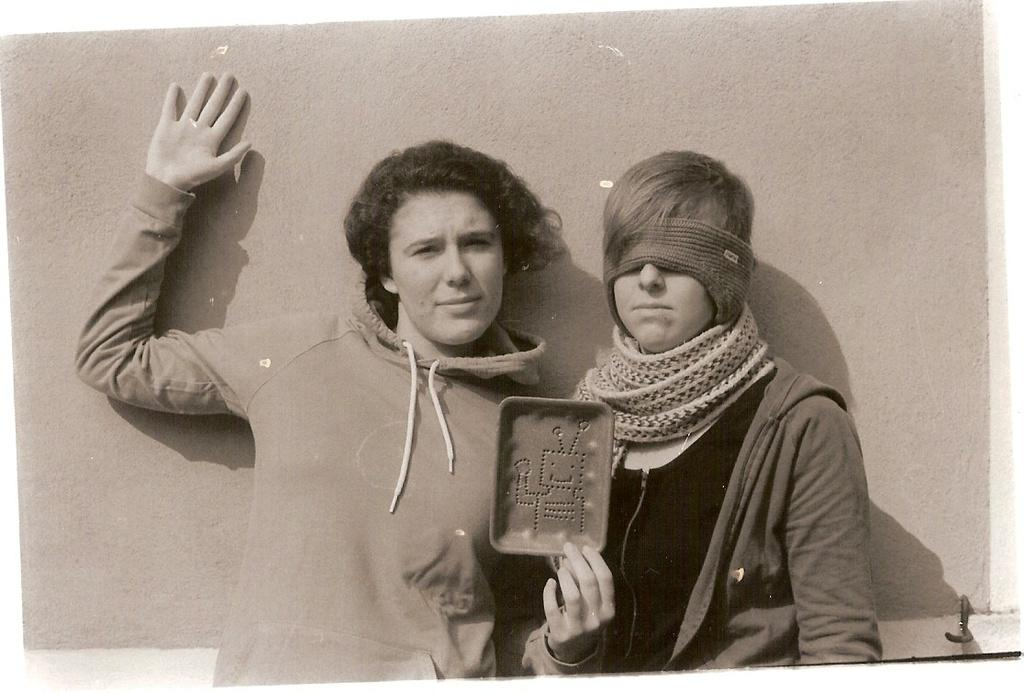How many people are in the image? There are two persons standing in the image. What is one of the persons holding in their hand? One of the persons is holding an object in their hand. What is covering the eyes of the other person? The other person is wearing a mask covering their eyes. What can be seen in the background of the image? There is a wall in the background of the image. What type of fish can be seen swimming in a basket in the image? There is no fish or basket present in the image. What show are the two persons attending in the image? The image does not provide any information about a show or event that the two persons might be attending. 